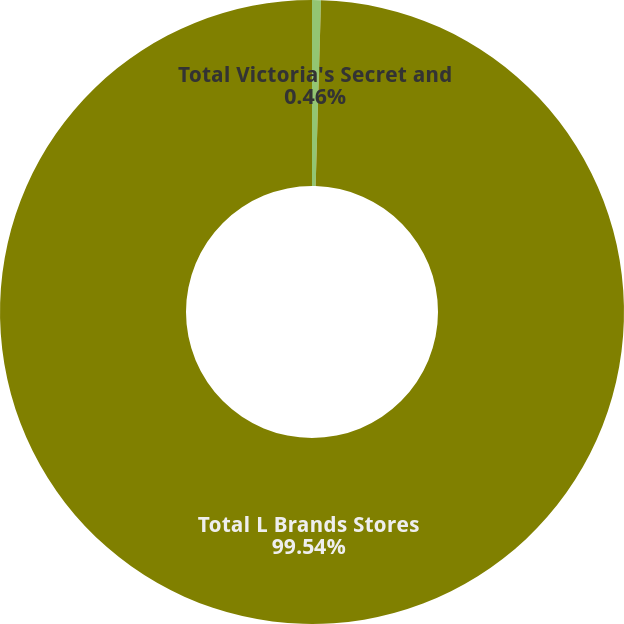Convert chart. <chart><loc_0><loc_0><loc_500><loc_500><pie_chart><fcel>Total Victoria's Secret and<fcel>Total L Brands Stores<nl><fcel>0.46%<fcel>99.54%<nl></chart> 